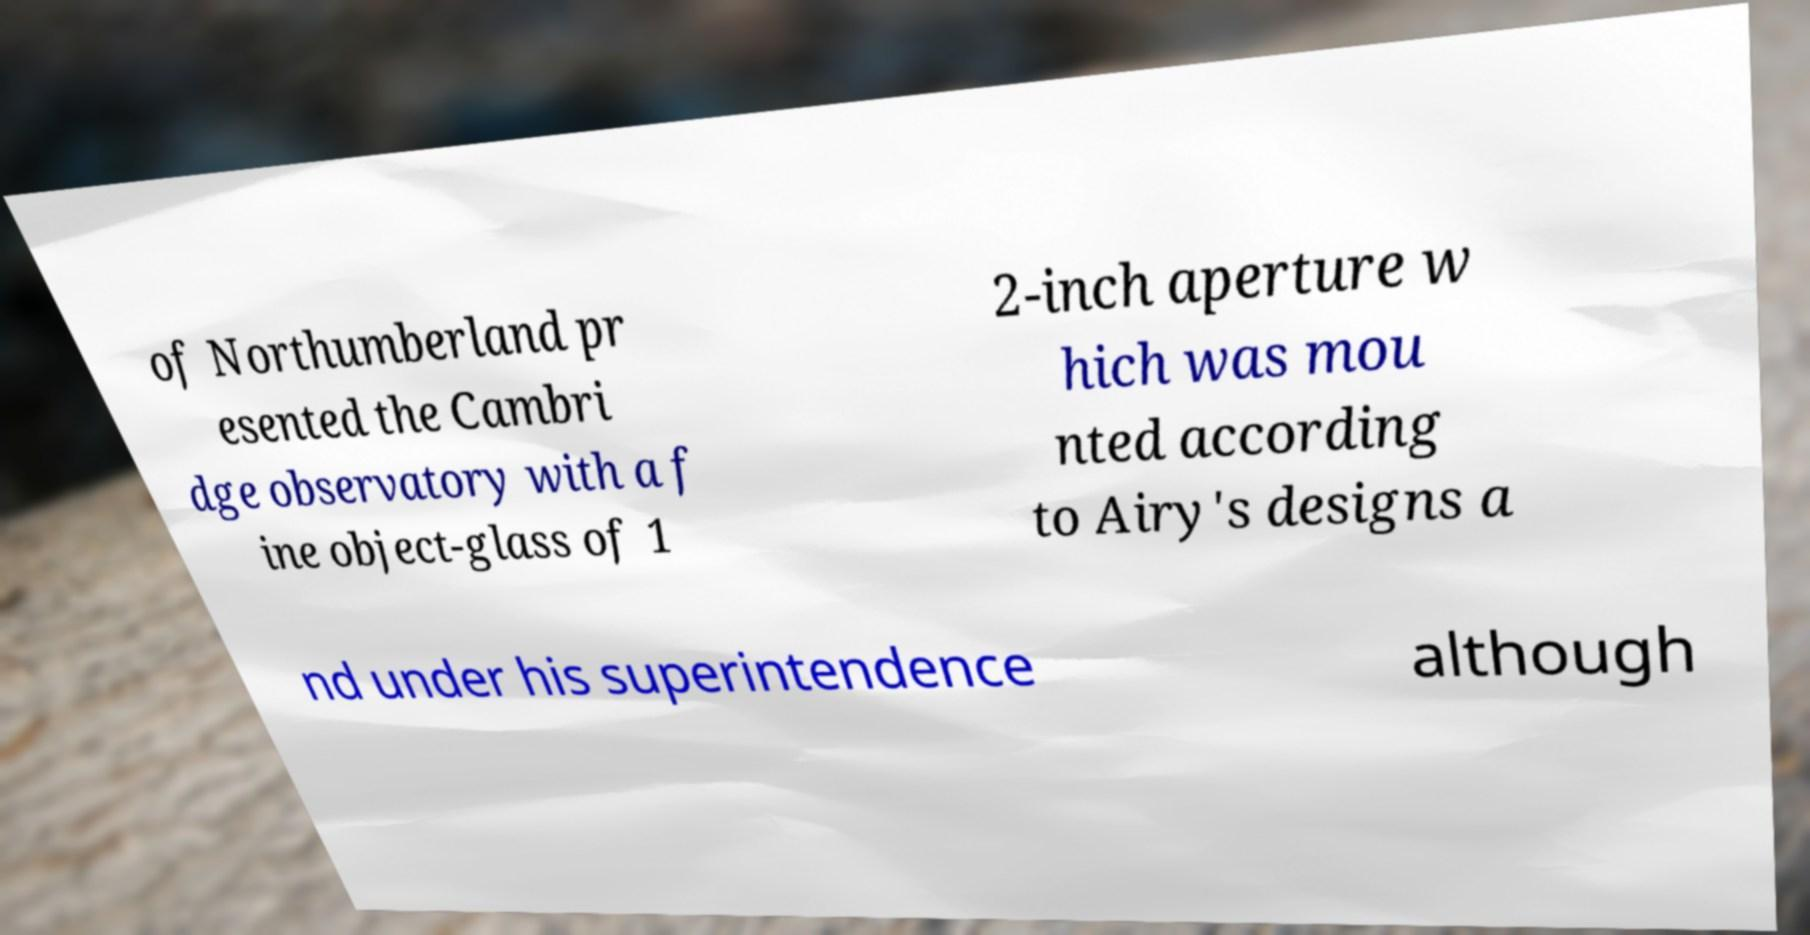Please read and relay the text visible in this image. What does it say? of Northumberland pr esented the Cambri dge observatory with a f ine object-glass of 1 2-inch aperture w hich was mou nted according to Airy's designs a nd under his superintendence although 